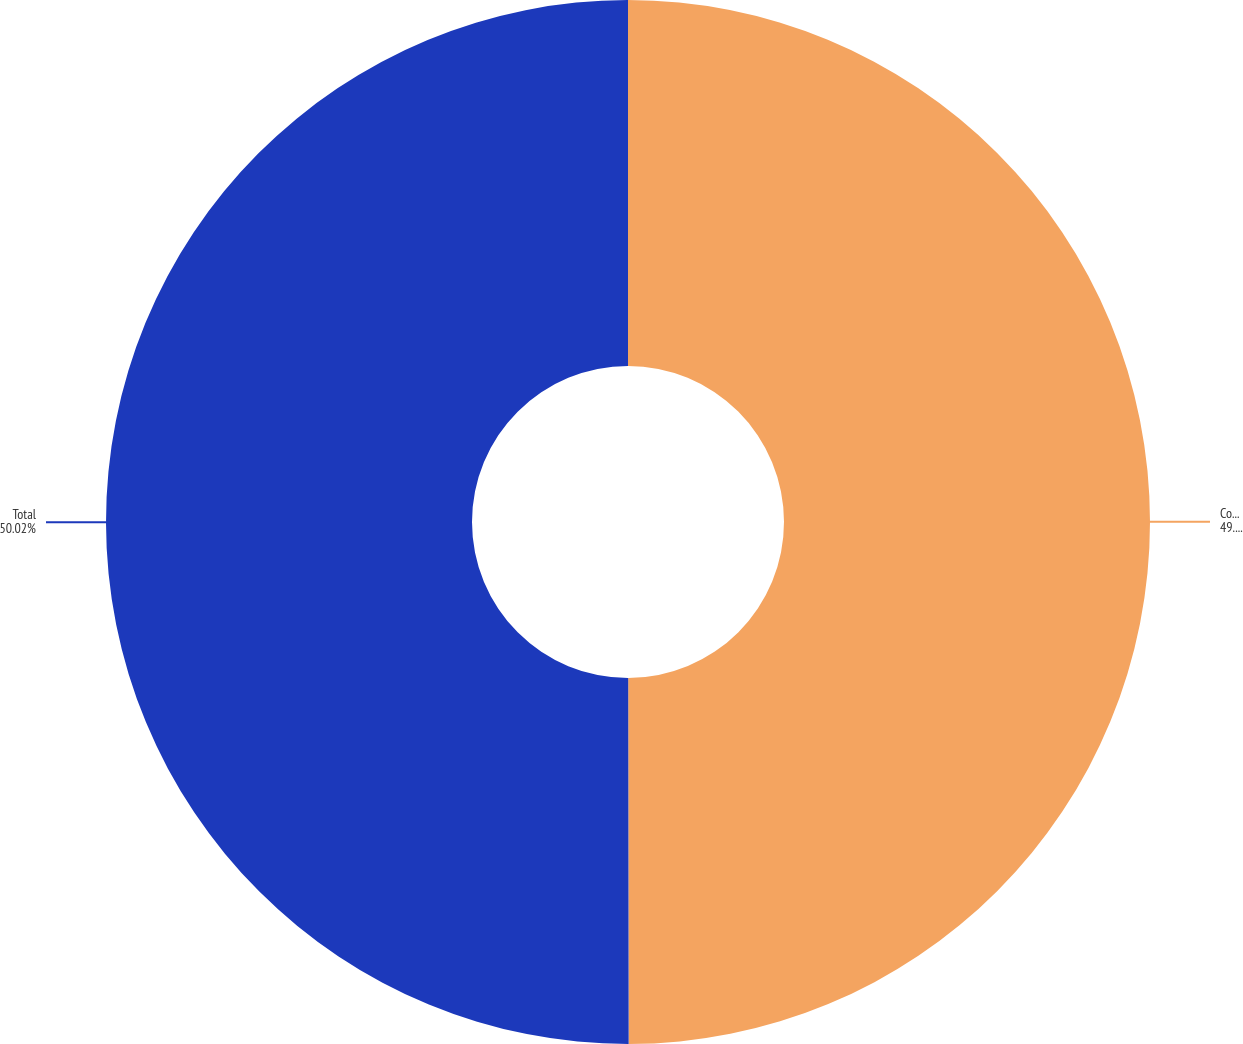Convert chart. <chart><loc_0><loc_0><loc_500><loc_500><pie_chart><fcel>Commercial and industrial<fcel>Total<nl><fcel>49.98%<fcel>50.02%<nl></chart> 